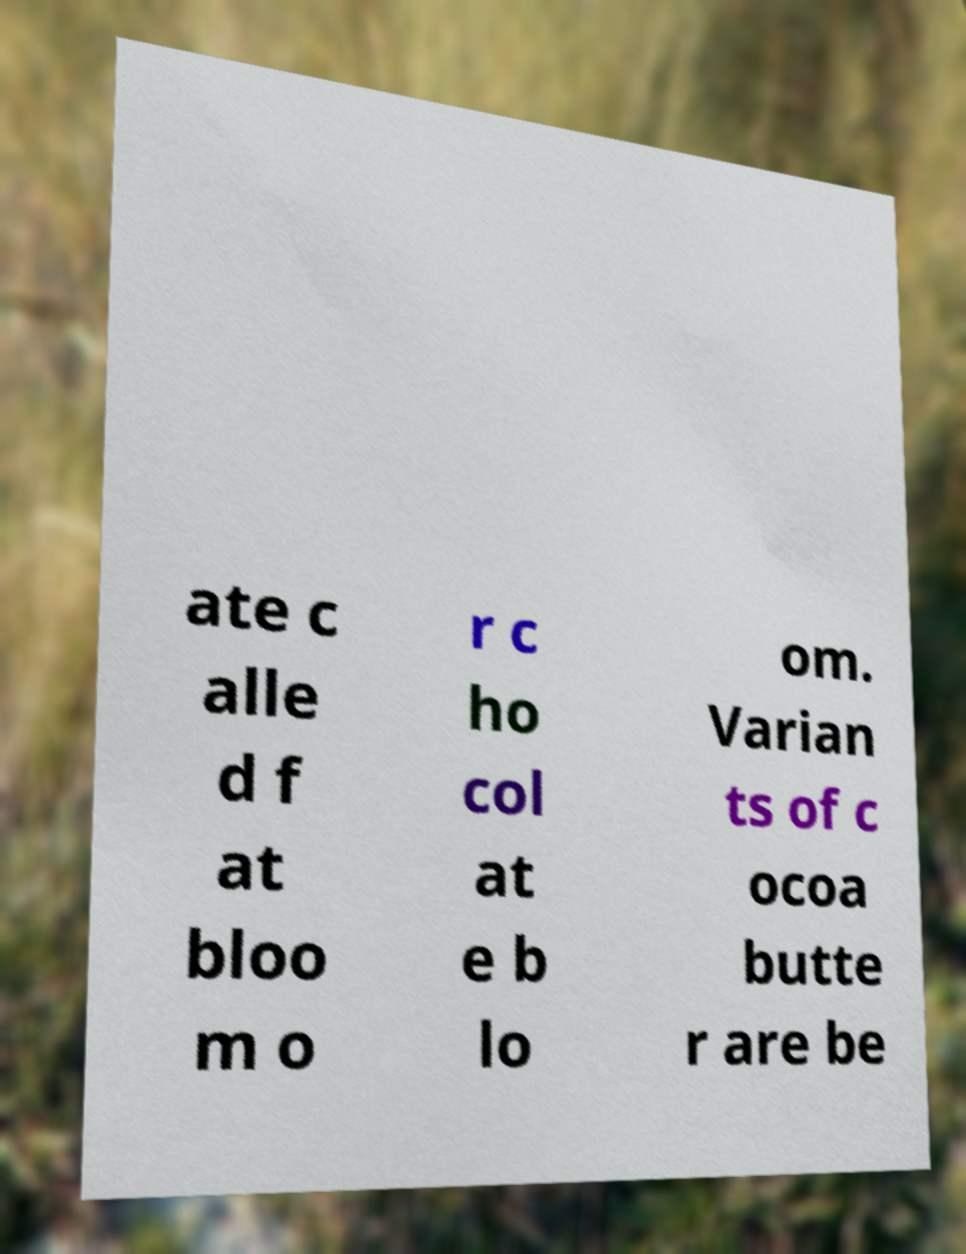For documentation purposes, I need the text within this image transcribed. Could you provide that? ate c alle d f at bloo m o r c ho col at e b lo om. Varian ts of c ocoa butte r are be 